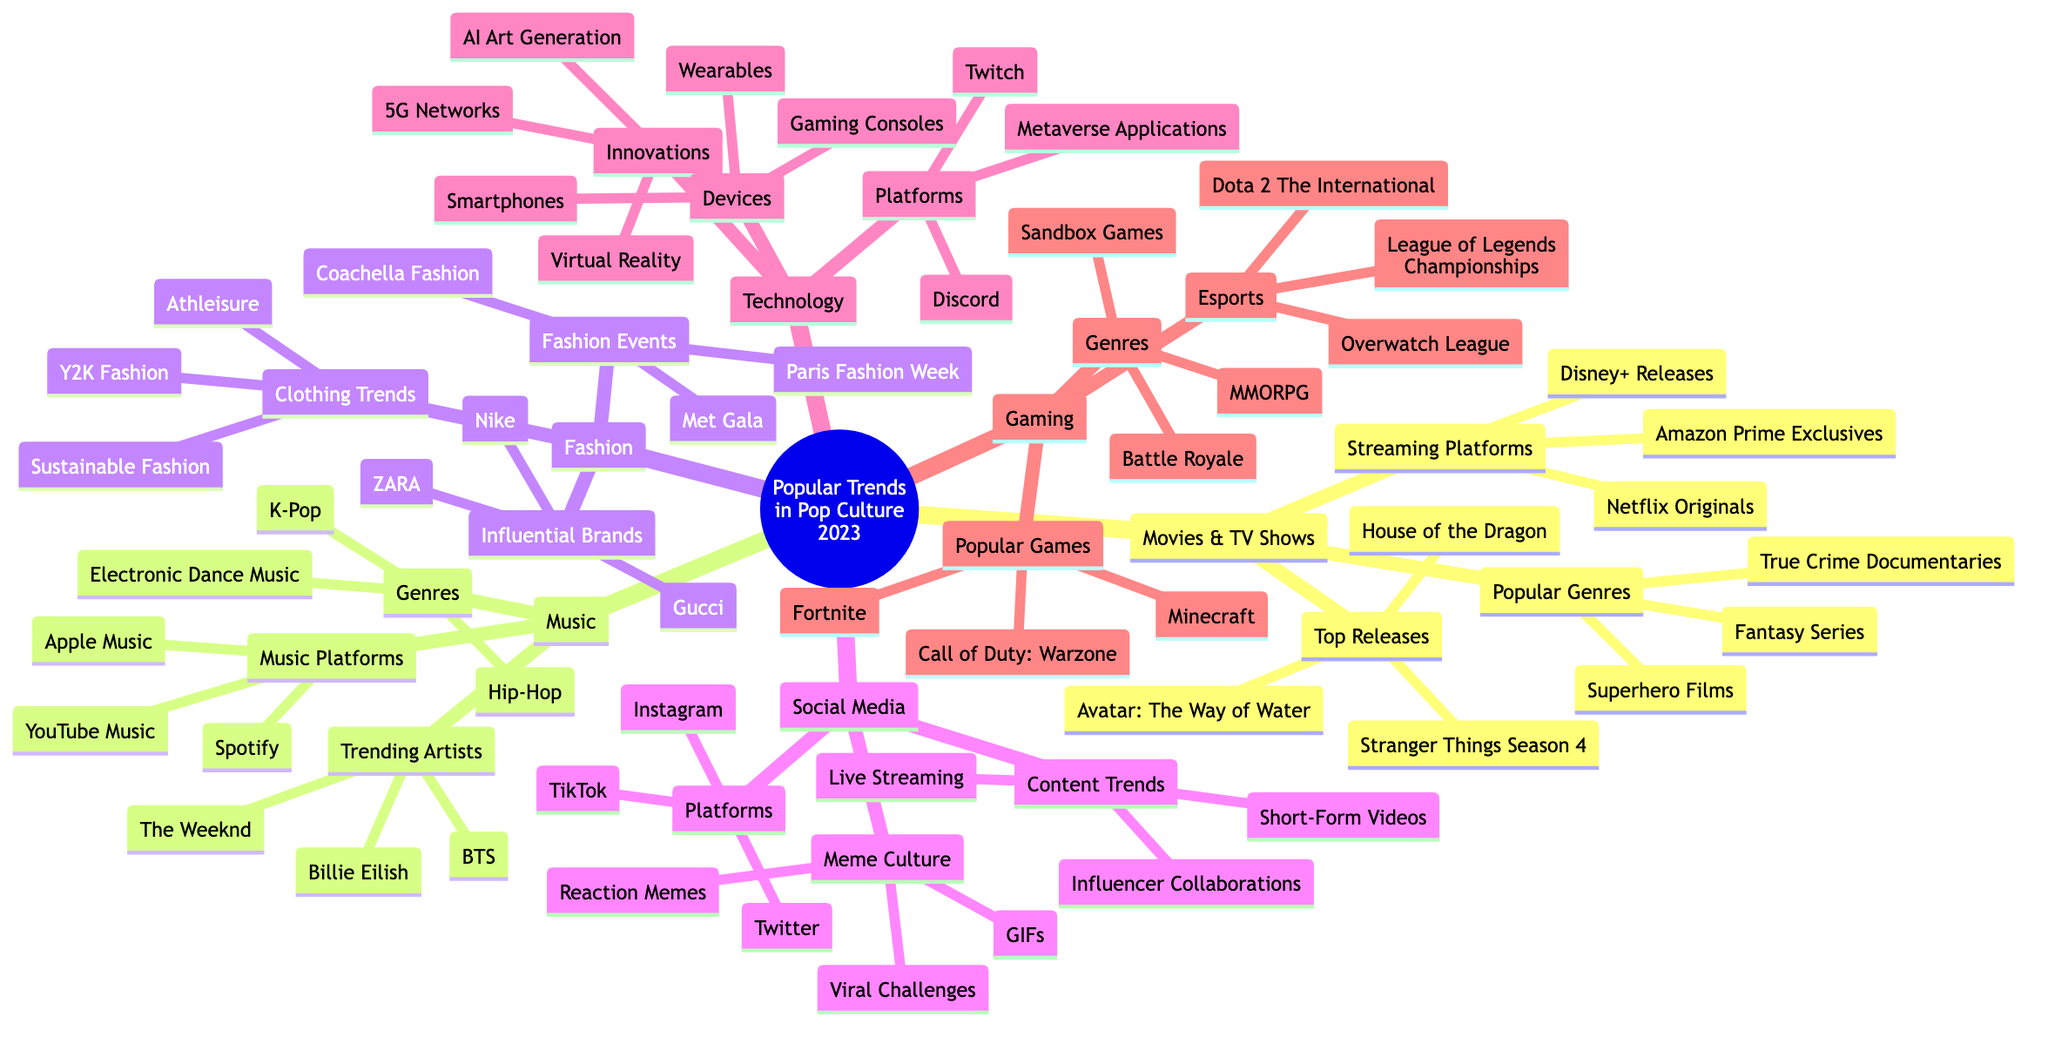What is the central topic of the mind map? The central topic is mentioned at the root of the diagram as "Popular Trends in Pop Culture 2023."
Answer: Popular Trends in Pop Culture 2023 How many main branches are in the diagram? There are six main branches stemming from the central topic, indicating key areas of pop culture trends.
Answer: 6 Which streaming platform is specifically mentioned under Movies & TV Shows? Looking at the sub-branch "Streaming Platforms," Netflix is listed as one of the examples provided.
Answer: Netflix Originals What genre of music is represented by BTS? Under the "Genres" sub-branch in the Music category, K-Pop is identified as the genre associated with BTS.
Answer: K-Pop What are the two influential brands listed in the Fashion branch? Under "Influential Brands," Gucci and Nike are mentioned as notable examples in the fashion industry.
Answer: Gucci, Nike Which popular game is found in the Gaming branch? The "Popular Games" sub-branch includes Fortnite as one of the top games listed in this category.
Answer: Fortnite Which two forms of content are trending on social media platforms? Within the "Content Trends" section, both Short-Form Videos and Live Streaming are highlighted as current trends.
Answer: Short-Form Videos, Live Streaming How are social media meme cultures represented in the mind map? The "Meme Culture" sub-branch describes elements like Viral Challenges and Reaction Memes that define current trends in memes.
Answer: Viral Challenges, Reaction Memes What device type is mentioned under the Technology branch? The "Devices" sub-branch identifies Smartphones as one of the types of devices discussed in technology.
Answer: Smartphones 